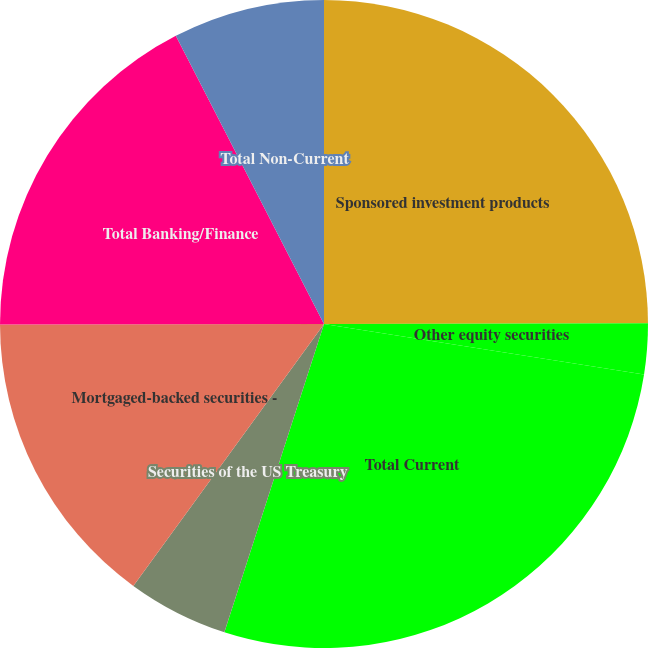<chart> <loc_0><loc_0><loc_500><loc_500><pie_chart><fcel>Sponsored investment products<fcel>Other equity securities<fcel>Total Current<fcel>Securities of the US Treasury<fcel>Mortgaged-backed securities -<fcel>Total Banking/Finance<fcel>Securities of US states and<fcel>Total Non-Current<nl><fcel>24.97%<fcel>2.52%<fcel>27.49%<fcel>5.04%<fcel>14.96%<fcel>17.47%<fcel>0.0%<fcel>7.56%<nl></chart> 